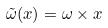Convert formula to latex. <formula><loc_0><loc_0><loc_500><loc_500>\tilde { \omega } ( x ) = \omega \times x</formula> 